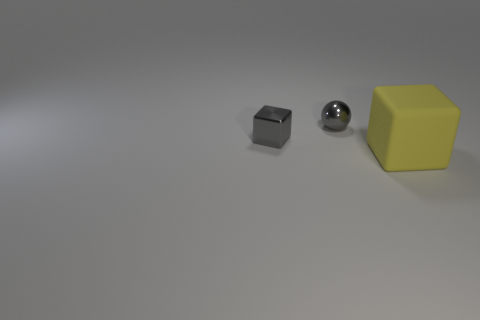What textures can be observed on the surfaces in the picture? The surfaces in the image display a variety of textures: the gray cube has a smooth, metallic texture that reflects light, the sphere has a similar smooth reflective finish, and the yellow cube shows a matt texture with a little light reflection. 